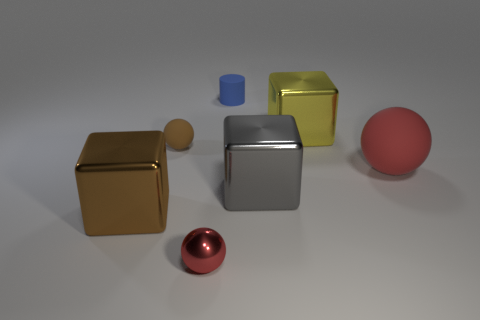Add 1 small metal balls. How many objects exist? 8 Subtract 3 spheres. How many spheres are left? 0 Subtract all brown cubes. How many cubes are left? 2 Subtract all matte spheres. How many spheres are left? 1 Subtract all cylinders. How many objects are left? 6 Subtract 0 gray spheres. How many objects are left? 7 Subtract all green spheres. Subtract all gray blocks. How many spheres are left? 3 Subtract all yellow cubes. How many brown balls are left? 1 Subtract all large cubes. Subtract all small things. How many objects are left? 1 Add 1 brown rubber things. How many brown rubber things are left? 2 